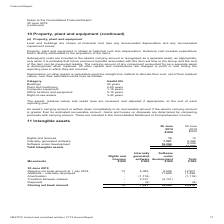From Nextdc's financial document, What does costs capitalised include? The document shows two values: external direct costs of materials and service and employee costs. Also, What was the total intangible assets in 2019? According to the financial document, 23,678 (in thousands). The relevant text states: "development 16,284 6,509 Total intangible assets 23,678 12,907..." Also, What was the value of Rights and licences in 2019 and 2018 respectively? The document shows two values: 13 and 13 (in thousands). From the document: "Rights and licences 13 13 Internally generated software 7,381 6,385 Software under development 16,284 6,509 Total intangib..." Also, can you calculate: What was the percentage change in internally generated software between 2018 and 2019? To answer this question, I need to perform calculations using the financial data. The calculation is: (7,381 - 6,385) / 6,385 , which equals 15.6 (percentage). This is based on the information: "icences 13 13 Internally generated software 7,381 6,385 Software under development 16,284 6,509 Total intangible assets 23,678 12,907 and licences 13 13 Internally generated software 7,381 6,385 Softw..." The key data points involved are: 6,385, 7,381. Also, can you calculate: What was the percentage change in software under development between 2018 and 2019? To answer this question, I need to perform calculations using the financial data. The calculation is: (16,284 - 6,509) / 6,509 , which equals 150.18 (percentage). This is based on the information: "are 7,381 6,385 Software under development 16,284 6,509 Total intangible assets 23,678 12,907 d software 7,381 6,385 Software under development 16,284 6,509 Total intangible assets 23,678 12,907..." The key data points involved are: 16,284, 6,509. Also, can you calculate: What was the percentage change in rights and licences between 2018 and 2019? I cannot find a specific answer to this question in the financial document. 